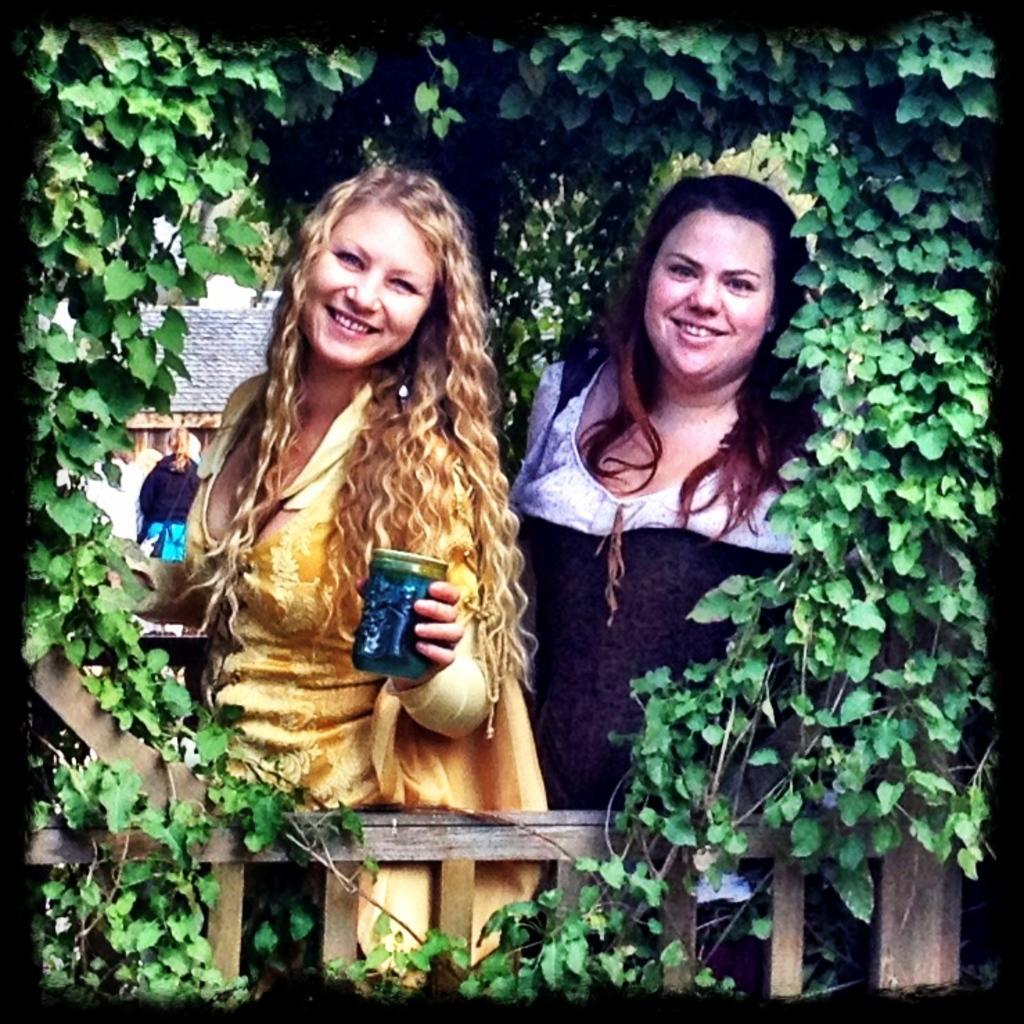Could you give a brief overview of what you see in this image? In this picture there is a woman standing and smiling and holding the object there is a woman standing and smiling. At the back there is a building and there is a person. In the foreground there is a railing and there is a creeper on the railing. 